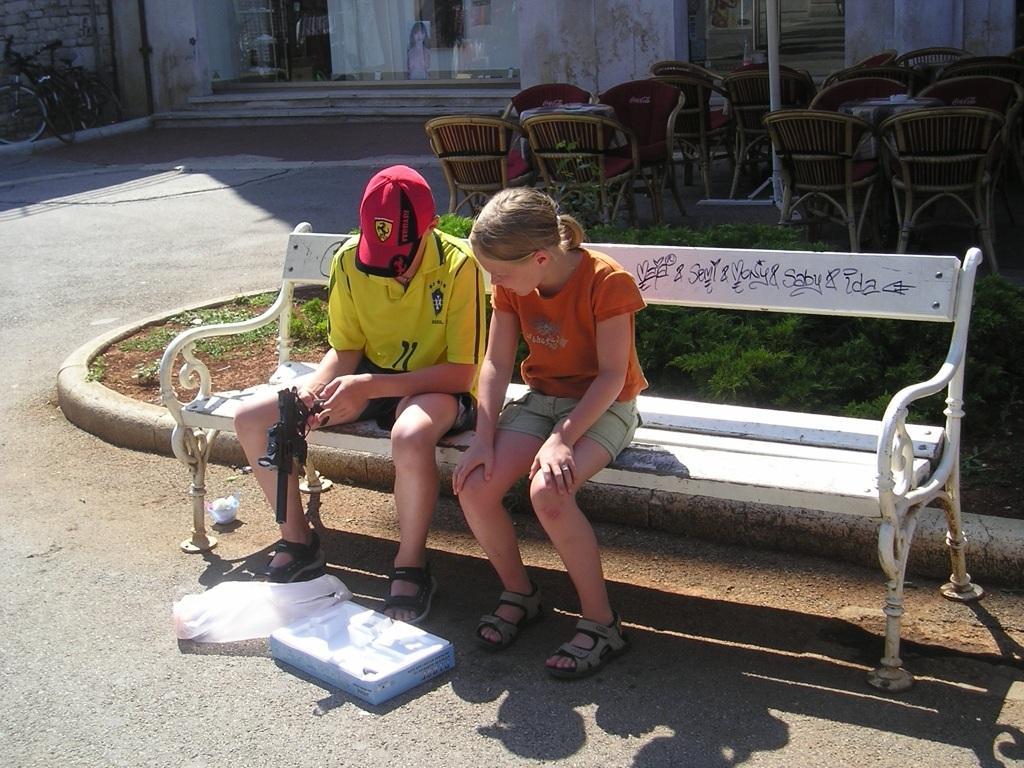How would you summarize this image in a sentence or two? In this picture we can see boy and girl sitting on a bench boy is holding gun in his hand and in front of them there is a box and in background we can see chairs, pole, steps, bicycle. 